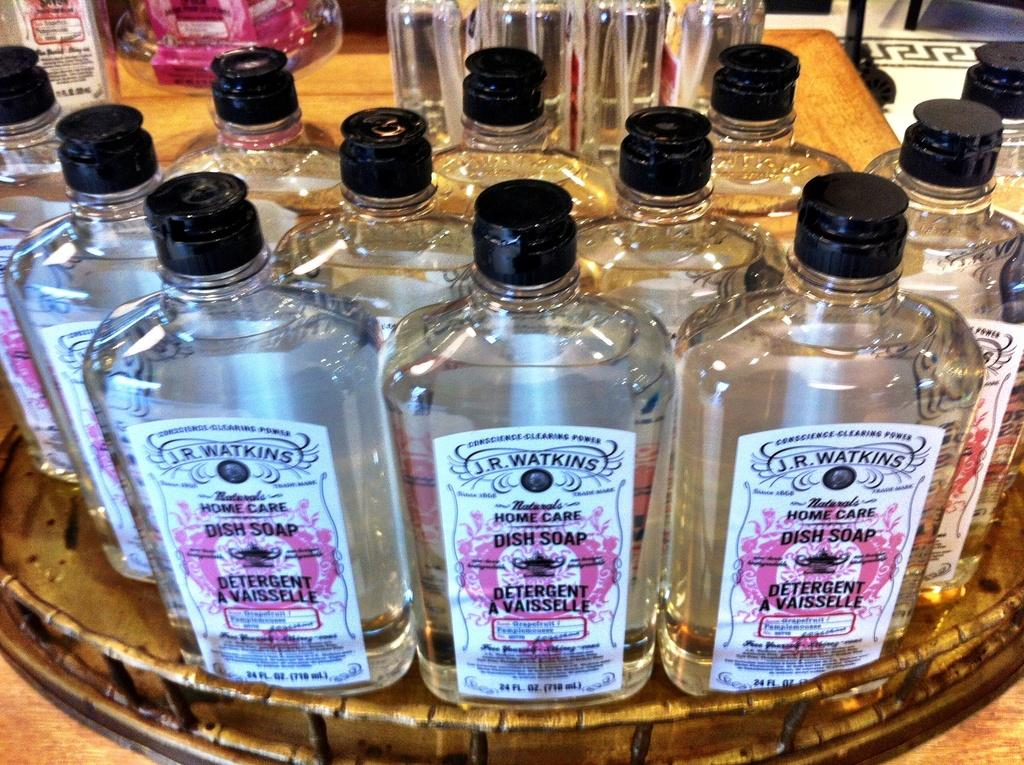<image>
Describe the image concisely. Man bottles of dish soaps on top of a wooden surface. 